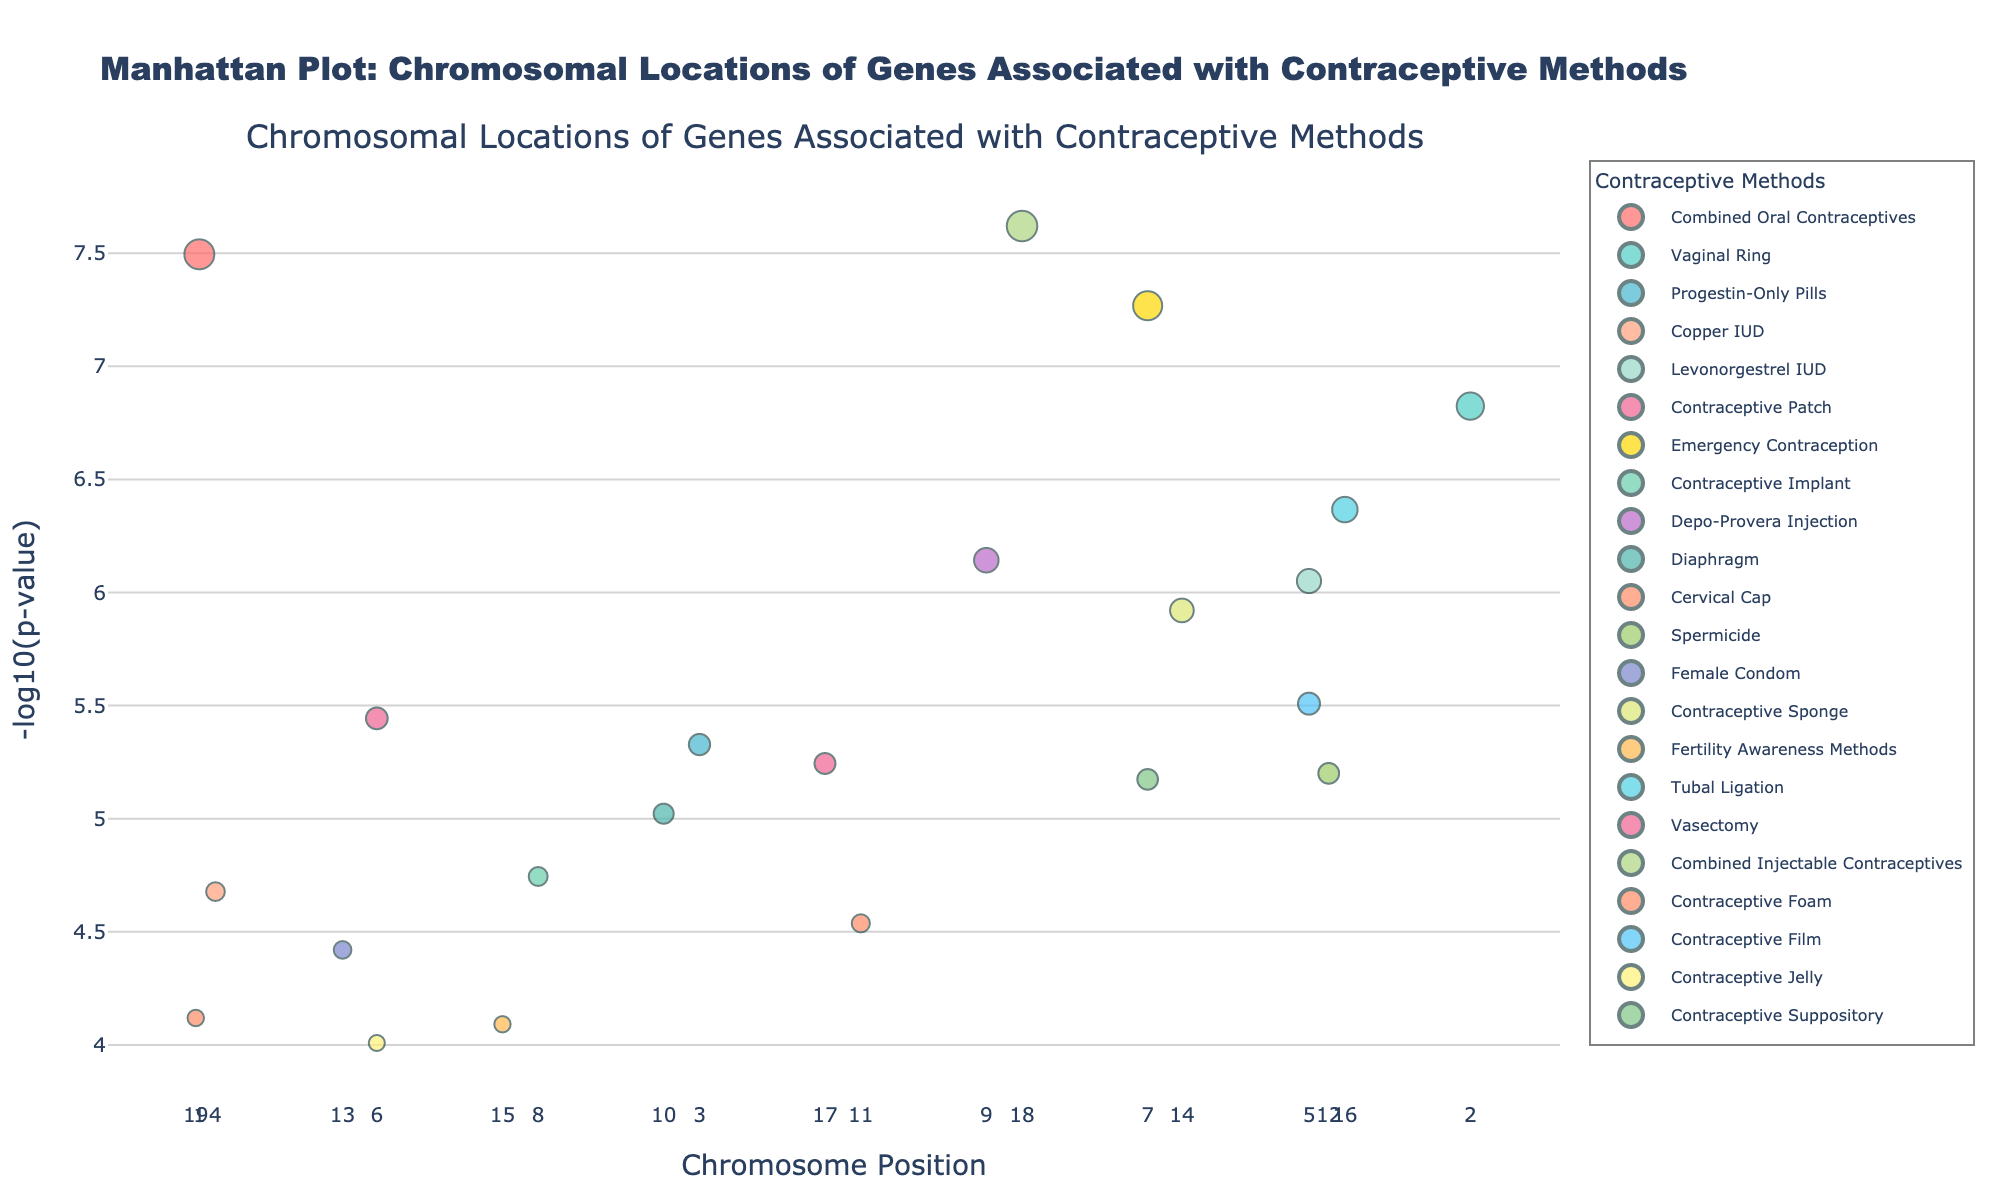What is the title of the plot? The title of the plot is displayed at the top in bold and larger font size, providing an overview of the figure.
Answer: Manhattan Plot: Chromosomal Locations of Genes Associated with Contraceptive Methods Which gene has the smallest p-value? The gene with the smallest p-value will have the highest -log10(p-value) on the vertical axis. Look for the topmost point on the plot.
Answer: CYP3A4 How many different contraceptive methods are represented in the plot? Each contraceptive method is represented by a unique color shown in the legend. Count the distinct entries in the legend.
Answer: 22 Which chromosome has the highest number of genes associated with contraceptive methods? Look for the chromosome number on the x-axis that appears most frequently with data points marked above it.
Answer: Chromosome 1 Which contraceptive method has the gene associated with Tubal Ligation and what is its -log10(p-value)? Locate the contraceptive method "Tubal Ligation" in the figure, identify its representative marker, and read the y-axis value for the corresponding data point.
Answer: Tubal Ligation; ~6.37 Are there any genes with -log10(p-value) greater than 7? Examine the vertical axis and check if any data points reach above the 7 mark.
Answer: Yes Which genes are associated with emergency contraception and where are they located? Search the legend for "Emergency Contraception," identify the color, and locate corresponding markers. Note down the gene names and their chromosomal positions.
Answer: CYP3A4 on Chromosome 7 Compare the -log10(p-value) of genes associated with "Combined Oral Contraceptives" and "Contraceptive Patch." Which has a higher value? Find and compare the y-values of genes for both contraceptive methods and determine which is higher.
Answer: Combined Oral Contraceptives has a higher value What's the median -log10(p-value) of the genes associated with "Depo-Provera Injection" and "Levonorgestrel IUD"? Locate the data points for the contraceptive methods, list the -log10(p-values), and find the median for each method and then average them.
Answer: 6.47 